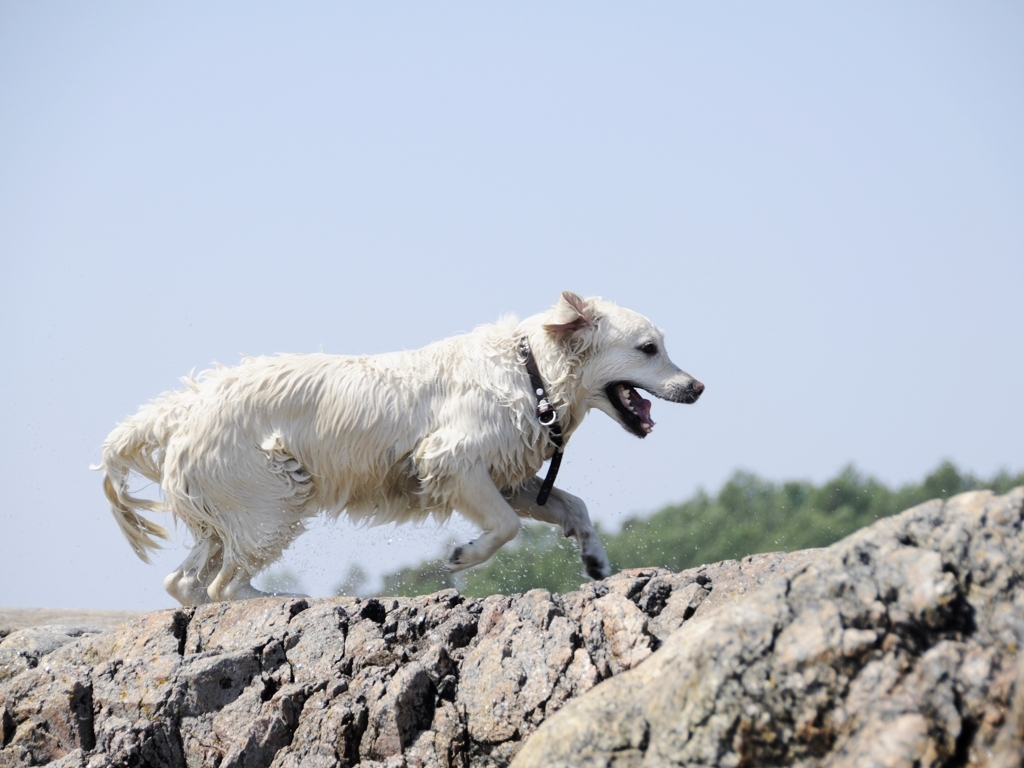Is there any overexposure in the image?
A. No
B. Yes
Answer with the option's letter from the given choices directly.
 A. 